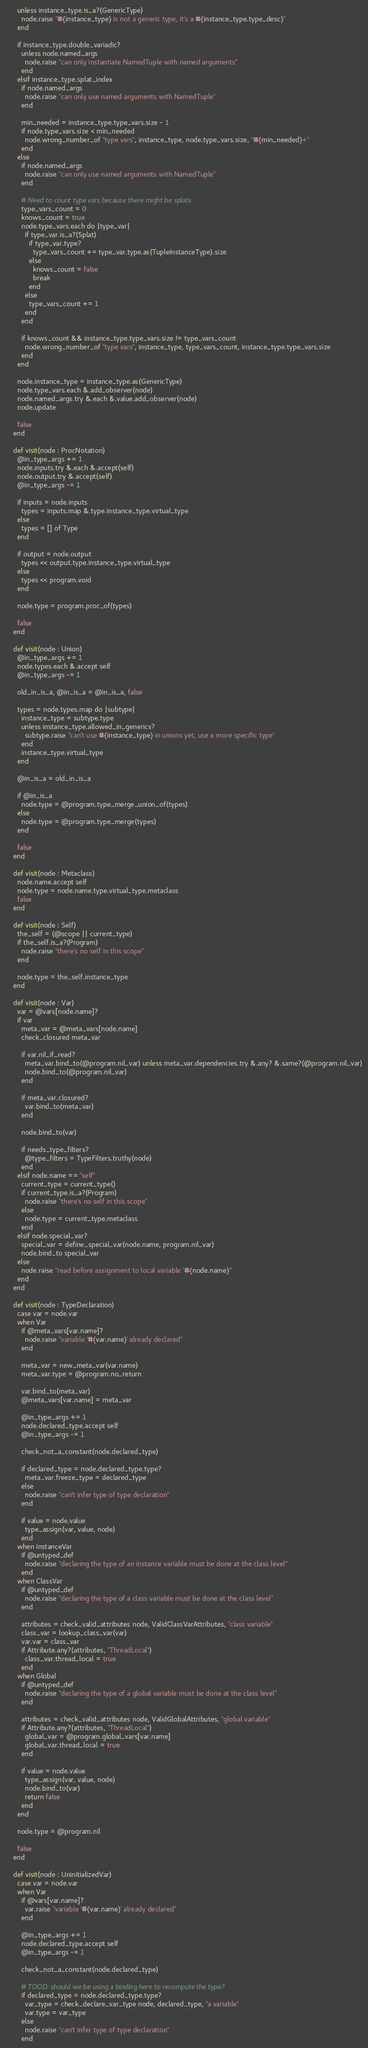Convert code to text. <code><loc_0><loc_0><loc_500><loc_500><_Crystal_>      unless instance_type.is_a?(GenericType)
        node.raise "#{instance_type} is not a generic type, it's a #{instance_type.type_desc}"
      end

      if instance_type.double_variadic?
        unless node.named_args
          node.raise "can only instantiate NamedTuple with named arguments"
        end
      elsif instance_type.splat_index
        if node.named_args
          node.raise "can only use named arguments with NamedTuple"
        end

        min_needed = instance_type.type_vars.size - 1
        if node.type_vars.size < min_needed
          node.wrong_number_of "type vars", instance_type, node.type_vars.size, "#{min_needed}+"
        end
      else
        if node.named_args
          node.raise "can only use named arguments with NamedTuple"
        end

        # Need to count type vars because there might be splats
        type_vars_count = 0
        knows_count = true
        node.type_vars.each do |type_var|
          if type_var.is_a?(Splat)
            if type_var.type?
              type_vars_count += type_var.type.as(TupleInstanceType).size
            else
              knows_count = false
              break
            end
          else
            type_vars_count += 1
          end
        end

        if knows_count && instance_type.type_vars.size != type_vars_count
          node.wrong_number_of "type vars", instance_type, type_vars_count, instance_type.type_vars.size
        end
      end

      node.instance_type = instance_type.as(GenericType)
      node.type_vars.each &.add_observer(node)
      node.named_args.try &.each &.value.add_observer(node)
      node.update

      false
    end

    def visit(node : ProcNotation)
      @in_type_args += 1
      node.inputs.try &.each &.accept(self)
      node.output.try &.accept(self)
      @in_type_args -= 1

      if inputs = node.inputs
        types = inputs.map &.type.instance_type.virtual_type
      else
        types = [] of Type
      end

      if output = node.output
        types << output.type.instance_type.virtual_type
      else
        types << program.void
      end

      node.type = program.proc_of(types)

      false
    end

    def visit(node : Union)
      @in_type_args += 1
      node.types.each &.accept self
      @in_type_args -= 1

      old_in_is_a, @in_is_a = @in_is_a, false

      types = node.types.map do |subtype|
        instance_type = subtype.type
        unless instance_type.allowed_in_generics?
          subtype.raise "can't use #{instance_type} in unions yet, use a more specific type"
        end
        instance_type.virtual_type
      end

      @in_is_a = old_in_is_a

      if @in_is_a
        node.type = @program.type_merge_union_of(types)
      else
        node.type = @program.type_merge(types)
      end

      false
    end

    def visit(node : Metaclass)
      node.name.accept self
      node.type = node.name.type.virtual_type.metaclass
      false
    end

    def visit(node : Self)
      the_self = (@scope || current_type)
      if the_self.is_a?(Program)
        node.raise "there's no self in this scope"
      end

      node.type = the_self.instance_type
    end

    def visit(node : Var)
      var = @vars[node.name]?
      if var
        meta_var = @meta_vars[node.name]
        check_closured meta_var

        if var.nil_if_read?
          meta_var.bind_to(@program.nil_var) unless meta_var.dependencies.try &.any? &.same?(@program.nil_var)
          node.bind_to(@program.nil_var)
        end

        if meta_var.closured?
          var.bind_to(meta_var)
        end

        node.bind_to(var)

        if needs_type_filters?
          @type_filters = TypeFilters.truthy(node)
        end
      elsif node.name == "self"
        current_type = current_type()
        if current_type.is_a?(Program)
          node.raise "there's no self in this scope"
        else
          node.type = current_type.metaclass
        end
      elsif node.special_var?
        special_var = define_special_var(node.name, program.nil_var)
        node.bind_to special_var
      else
        node.raise "read before assignment to local variable '#{node.name}'"
      end
    end

    def visit(node : TypeDeclaration)
      case var = node.var
      when Var
        if @meta_vars[var.name]?
          node.raise "variable '#{var.name}' already declared"
        end

        meta_var = new_meta_var(var.name)
        meta_var.type = @program.no_return

        var.bind_to(meta_var)
        @meta_vars[var.name] = meta_var

        @in_type_args += 1
        node.declared_type.accept self
        @in_type_args -= 1

        check_not_a_constant(node.declared_type)

        if declared_type = node.declared_type.type?
          meta_var.freeze_type = declared_type
        else
          node.raise "can't infer type of type declaration"
        end

        if value = node.value
          type_assign(var, value, node)
        end
      when InstanceVar
        if @untyped_def
          node.raise "declaring the type of an instance variable must be done at the class level"
        end
      when ClassVar
        if @untyped_def
          node.raise "declaring the type of a class variable must be done at the class level"
        end

        attributes = check_valid_attributes node, ValidClassVarAttributes, "class variable"
        class_var = lookup_class_var(var)
        var.var = class_var
        if Attribute.any?(attributes, "ThreadLocal")
          class_var.thread_local = true
        end
      when Global
        if @untyped_def
          node.raise "declaring the type of a global variable must be done at the class level"
        end

        attributes = check_valid_attributes node, ValidGlobalAttributes, "global variable"
        if Attribute.any?(attributes, "ThreadLocal")
          global_var = @program.global_vars[var.name]
          global_var.thread_local = true
        end

        if value = node.value
          type_assign(var, value, node)
          node.bind_to(var)
          return false
        end
      end

      node.type = @program.nil

      false
    end

    def visit(node : UninitializedVar)
      case var = node.var
      when Var
        if @vars[var.name]?
          var.raise "variable '#{var.name}' already declared"
        end

        @in_type_args += 1
        node.declared_type.accept self
        @in_type_args -= 1

        check_not_a_constant(node.declared_type)

        # TOOD: should we be using a binding here to recompute the type?
        if declared_type = node.declared_type.type?
          var_type = check_declare_var_type node, declared_type, "a variable"
          var.type = var_type
        else
          node.raise "can't infer type of type declaration"
        end
</code> 